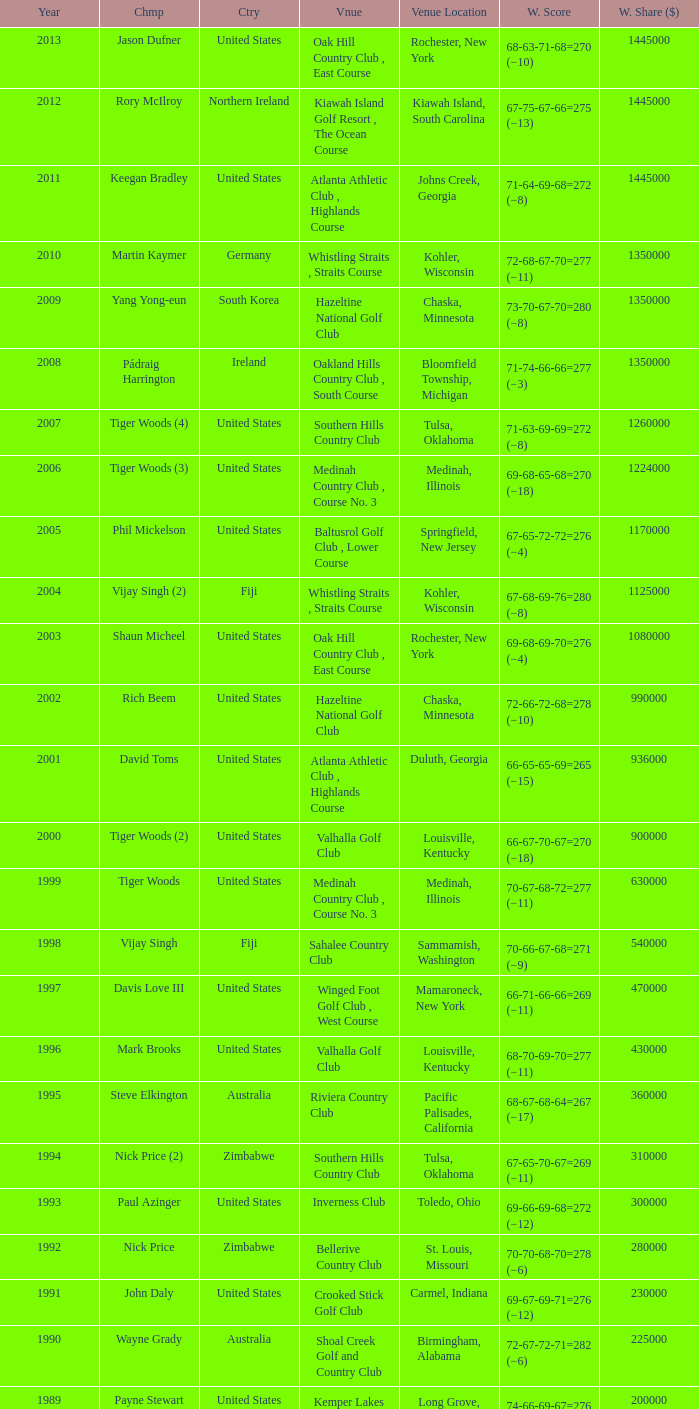List all winning scores from 1982. 63-69-68-72=272 (−8). 